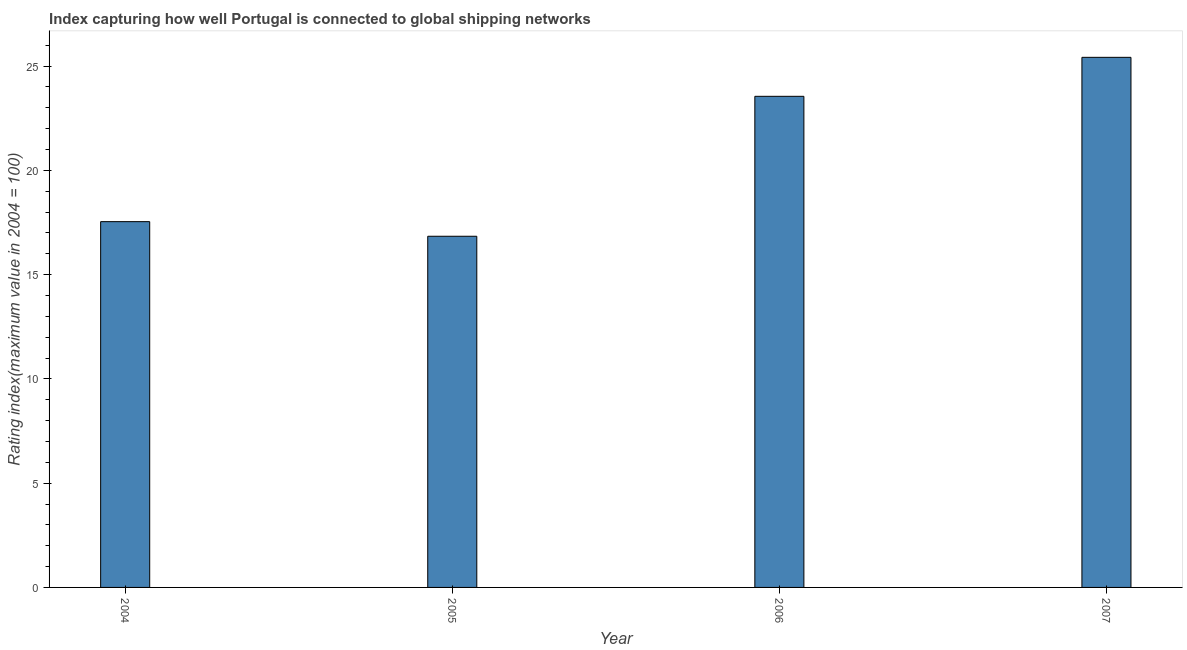Does the graph contain any zero values?
Your answer should be very brief. No. Does the graph contain grids?
Ensure brevity in your answer.  No. What is the title of the graph?
Your answer should be compact. Index capturing how well Portugal is connected to global shipping networks. What is the label or title of the Y-axis?
Your answer should be compact. Rating index(maximum value in 2004 = 100). What is the liner shipping connectivity index in 2006?
Provide a short and direct response. 23.55. Across all years, what is the maximum liner shipping connectivity index?
Offer a terse response. 25.42. Across all years, what is the minimum liner shipping connectivity index?
Ensure brevity in your answer.  16.84. In which year was the liner shipping connectivity index maximum?
Offer a very short reply. 2007. What is the sum of the liner shipping connectivity index?
Give a very brief answer. 83.35. What is the difference between the liner shipping connectivity index in 2006 and 2007?
Make the answer very short. -1.87. What is the average liner shipping connectivity index per year?
Keep it short and to the point. 20.84. What is the median liner shipping connectivity index?
Give a very brief answer. 20.55. Do a majority of the years between 2007 and 2005 (inclusive) have liner shipping connectivity index greater than 20 ?
Provide a succinct answer. Yes. What is the ratio of the liner shipping connectivity index in 2005 to that in 2006?
Offer a terse response. 0.71. Is the liner shipping connectivity index in 2004 less than that in 2007?
Offer a terse response. Yes. What is the difference between the highest and the second highest liner shipping connectivity index?
Your answer should be compact. 1.87. What is the difference between the highest and the lowest liner shipping connectivity index?
Provide a short and direct response. 8.58. Are all the bars in the graph horizontal?
Provide a short and direct response. No. How many years are there in the graph?
Ensure brevity in your answer.  4. What is the difference between two consecutive major ticks on the Y-axis?
Your answer should be compact. 5. Are the values on the major ticks of Y-axis written in scientific E-notation?
Keep it short and to the point. No. What is the Rating index(maximum value in 2004 = 100) in 2004?
Give a very brief answer. 17.54. What is the Rating index(maximum value in 2004 = 100) in 2005?
Ensure brevity in your answer.  16.84. What is the Rating index(maximum value in 2004 = 100) in 2006?
Offer a very short reply. 23.55. What is the Rating index(maximum value in 2004 = 100) in 2007?
Your answer should be compact. 25.42. What is the difference between the Rating index(maximum value in 2004 = 100) in 2004 and 2005?
Keep it short and to the point. 0.7. What is the difference between the Rating index(maximum value in 2004 = 100) in 2004 and 2006?
Your response must be concise. -6.01. What is the difference between the Rating index(maximum value in 2004 = 100) in 2004 and 2007?
Offer a terse response. -7.88. What is the difference between the Rating index(maximum value in 2004 = 100) in 2005 and 2006?
Your answer should be compact. -6.71. What is the difference between the Rating index(maximum value in 2004 = 100) in 2005 and 2007?
Your response must be concise. -8.58. What is the difference between the Rating index(maximum value in 2004 = 100) in 2006 and 2007?
Offer a terse response. -1.87. What is the ratio of the Rating index(maximum value in 2004 = 100) in 2004 to that in 2005?
Keep it short and to the point. 1.04. What is the ratio of the Rating index(maximum value in 2004 = 100) in 2004 to that in 2006?
Your answer should be very brief. 0.74. What is the ratio of the Rating index(maximum value in 2004 = 100) in 2004 to that in 2007?
Provide a short and direct response. 0.69. What is the ratio of the Rating index(maximum value in 2004 = 100) in 2005 to that in 2006?
Offer a very short reply. 0.71. What is the ratio of the Rating index(maximum value in 2004 = 100) in 2005 to that in 2007?
Offer a terse response. 0.66. What is the ratio of the Rating index(maximum value in 2004 = 100) in 2006 to that in 2007?
Offer a very short reply. 0.93. 